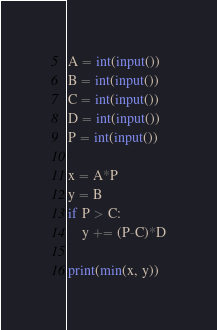<code> <loc_0><loc_0><loc_500><loc_500><_Python_>A = int(input())
B = int(input())
C = int(input())
D = int(input())
P = int(input())

x = A*P
y = B
if P > C:
    y += (P-C)*D

print(min(x, y))
</code> 